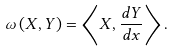<formula> <loc_0><loc_0><loc_500><loc_500>\omega \left ( X , Y \right ) = \left \langle X , \frac { d Y } { d x } \right \rangle .</formula> 